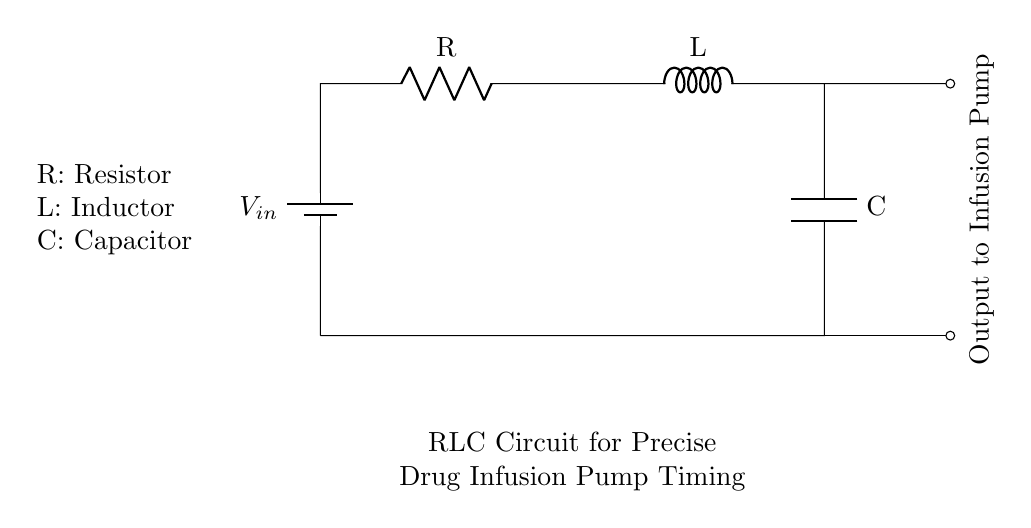What are the components of this circuit? The circuit consists of a resistor, an inductor, and a capacitor, which are standard components in an RLC circuit. The labels R, L, and C indicate their respective components in the diagram.
Answer: Resistor, Inductor, Capacitor What is the input voltage of the circuit? The input voltage, labeled as Vin in the circuit diagram, is the voltage supplied to the circuit. It is represented at the top of the circuit, connected to the resistor.
Answer: Vin How are the components connected in this circuit? The components are connected in series, with the current flowing through the resistor first, followed by the inductor and finally the capacitor before returning to the voltage source.
Answer: In series What is the purpose of the capacitor in this RLC circuit? The purpose of the capacitor is to store electrical energy and assist in timing the output voltage to the infusion pump. It affects the circuit's frequency response and stability for the timing application.
Answer: Timing How does the inductor influence the current in this circuit? The inductor opposes changes in current due to its property of inductance, which thereby affects the overall current flow and timing characteristics of the circuit. The greater the inductance, the more it resists changes to the current.
Answer: Resists changes in current What characteristics define an RLC circuit's resonant frequency? The resonant frequency is determined by the values of the resistor, inductor, and capacitor in the circuit. It can be calculated using the formula for resonance, which involves these component values.
Answer: R, L, C values 